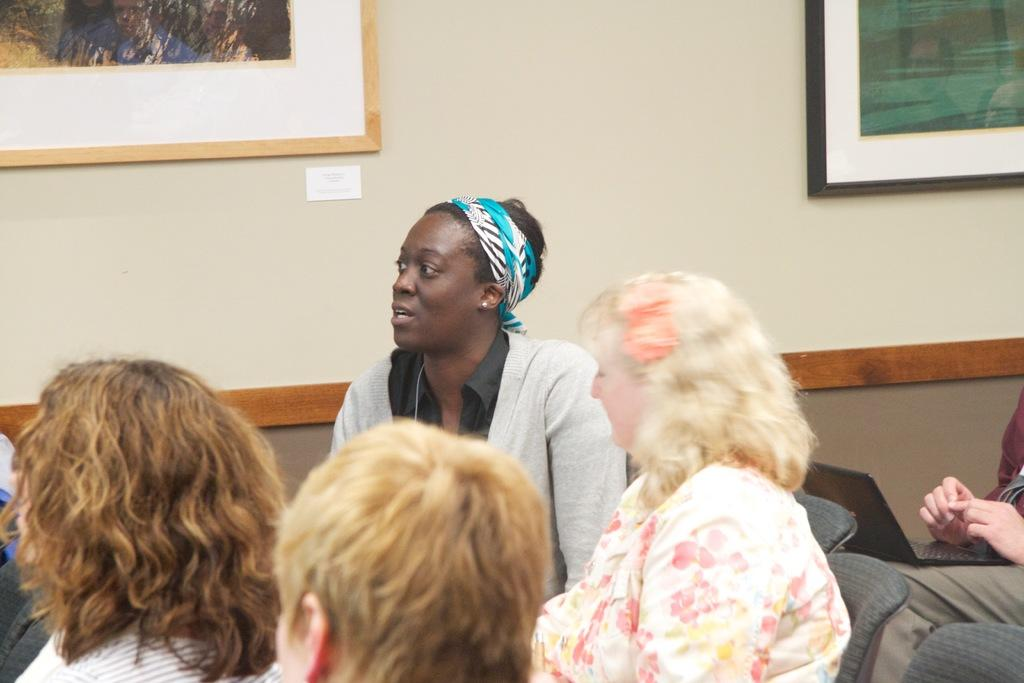How many people are in the image? There is a group of persons in the image. What are the persons in the image doing? The persons are sitting in chairs. Can you describe any objects that one of the persons is holding? One person is holding a laptop. What can be seen behind the persons in the image? There is a wall visible in the image. What is on the wall? There are photo frames on the wall. What type of hill can be seen in the background of the image? There is no hill visible in the image; it features a group of persons sitting in chairs with a wall and photo frames in the background. 